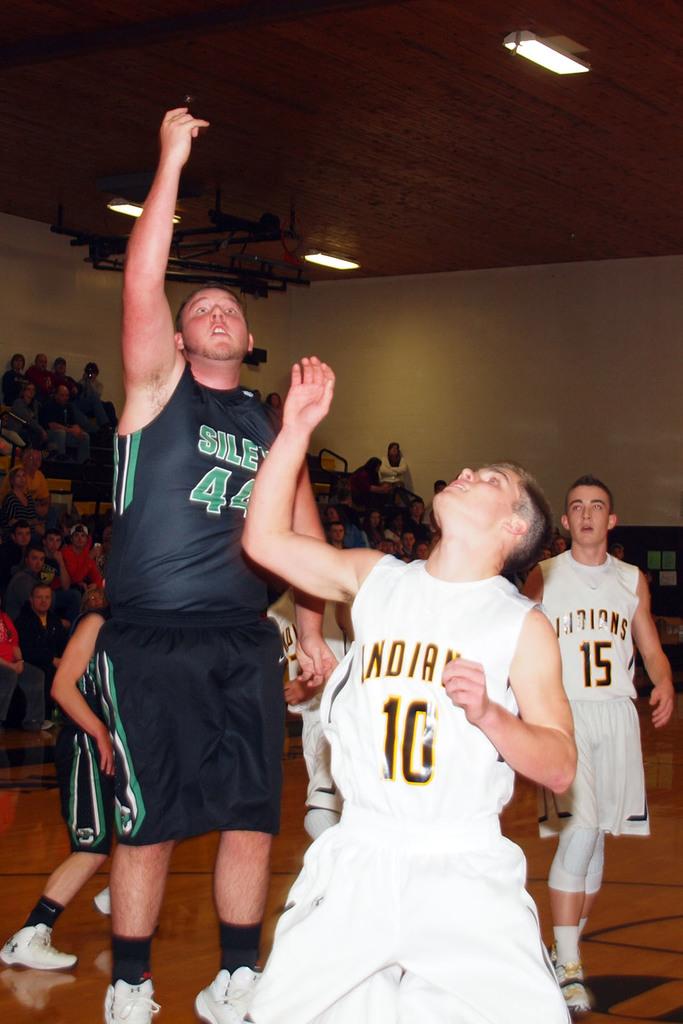Is player 15 there?
Make the answer very short. Yes. What is the name of the white team?
Keep it short and to the point. Indians. 